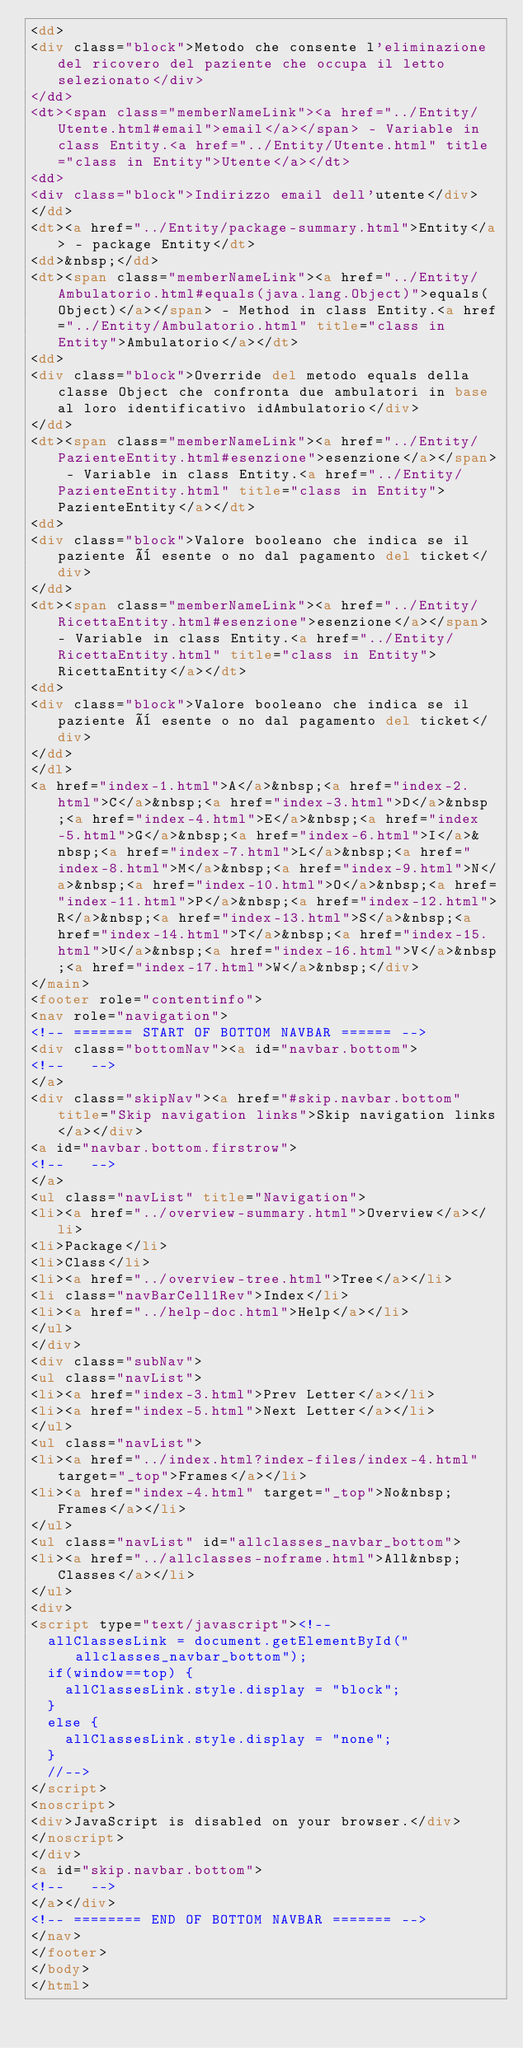<code> <loc_0><loc_0><loc_500><loc_500><_HTML_><dd>
<div class="block">Metodo che consente l'eliminazione del ricovero del paziente che occupa il letto selezionato</div>
</dd>
<dt><span class="memberNameLink"><a href="../Entity/Utente.html#email">email</a></span> - Variable in class Entity.<a href="../Entity/Utente.html" title="class in Entity">Utente</a></dt>
<dd>
<div class="block">Indirizzo email dell'utente</div>
</dd>
<dt><a href="../Entity/package-summary.html">Entity</a> - package Entity</dt>
<dd>&nbsp;</dd>
<dt><span class="memberNameLink"><a href="../Entity/Ambulatorio.html#equals(java.lang.Object)">equals(Object)</a></span> - Method in class Entity.<a href="../Entity/Ambulatorio.html" title="class in Entity">Ambulatorio</a></dt>
<dd>
<div class="block">Override del metodo equals della classe Object che confronta due ambulatori in base al loro identificativo idAmbulatorio</div>
</dd>
<dt><span class="memberNameLink"><a href="../Entity/PazienteEntity.html#esenzione">esenzione</a></span> - Variable in class Entity.<a href="../Entity/PazienteEntity.html" title="class in Entity">PazienteEntity</a></dt>
<dd>
<div class="block">Valore booleano che indica se il paziente è esente o no dal pagamento del ticket</div>
</dd>
<dt><span class="memberNameLink"><a href="../Entity/RicettaEntity.html#esenzione">esenzione</a></span> - Variable in class Entity.<a href="../Entity/RicettaEntity.html" title="class in Entity">RicettaEntity</a></dt>
<dd>
<div class="block">Valore booleano che indica se il paziente è esente o no dal pagamento del ticket</div>
</dd>
</dl>
<a href="index-1.html">A</a>&nbsp;<a href="index-2.html">C</a>&nbsp;<a href="index-3.html">D</a>&nbsp;<a href="index-4.html">E</a>&nbsp;<a href="index-5.html">G</a>&nbsp;<a href="index-6.html">I</a>&nbsp;<a href="index-7.html">L</a>&nbsp;<a href="index-8.html">M</a>&nbsp;<a href="index-9.html">N</a>&nbsp;<a href="index-10.html">O</a>&nbsp;<a href="index-11.html">P</a>&nbsp;<a href="index-12.html">R</a>&nbsp;<a href="index-13.html">S</a>&nbsp;<a href="index-14.html">T</a>&nbsp;<a href="index-15.html">U</a>&nbsp;<a href="index-16.html">V</a>&nbsp;<a href="index-17.html">W</a>&nbsp;</div>
</main>
<footer role="contentinfo">
<nav role="navigation">
<!-- ======= START OF BOTTOM NAVBAR ====== -->
<div class="bottomNav"><a id="navbar.bottom">
<!--   -->
</a>
<div class="skipNav"><a href="#skip.navbar.bottom" title="Skip navigation links">Skip navigation links</a></div>
<a id="navbar.bottom.firstrow">
<!--   -->
</a>
<ul class="navList" title="Navigation">
<li><a href="../overview-summary.html">Overview</a></li>
<li>Package</li>
<li>Class</li>
<li><a href="../overview-tree.html">Tree</a></li>
<li class="navBarCell1Rev">Index</li>
<li><a href="../help-doc.html">Help</a></li>
</ul>
</div>
<div class="subNav">
<ul class="navList">
<li><a href="index-3.html">Prev Letter</a></li>
<li><a href="index-5.html">Next Letter</a></li>
</ul>
<ul class="navList">
<li><a href="../index.html?index-files/index-4.html" target="_top">Frames</a></li>
<li><a href="index-4.html" target="_top">No&nbsp;Frames</a></li>
</ul>
<ul class="navList" id="allclasses_navbar_bottom">
<li><a href="../allclasses-noframe.html">All&nbsp;Classes</a></li>
</ul>
<div>
<script type="text/javascript"><!--
  allClassesLink = document.getElementById("allclasses_navbar_bottom");
  if(window==top) {
    allClassesLink.style.display = "block";
  }
  else {
    allClassesLink.style.display = "none";
  }
  //-->
</script>
<noscript>
<div>JavaScript is disabled on your browser.</div>
</noscript>
</div>
<a id="skip.navbar.bottom">
<!--   -->
</a></div>
<!-- ======== END OF BOTTOM NAVBAR ======= -->
</nav>
</footer>
</body>
</html>
</code> 